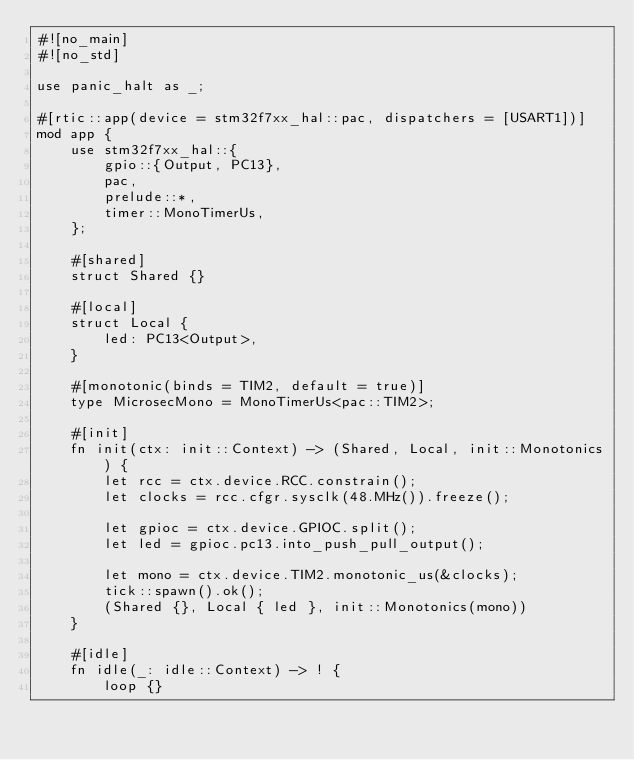Convert code to text. <code><loc_0><loc_0><loc_500><loc_500><_Rust_>#![no_main]
#![no_std]

use panic_halt as _;

#[rtic::app(device = stm32f7xx_hal::pac, dispatchers = [USART1])]
mod app {
    use stm32f7xx_hal::{
        gpio::{Output, PC13},
        pac,
        prelude::*,
        timer::MonoTimerUs,
    };

    #[shared]
    struct Shared {}

    #[local]
    struct Local {
        led: PC13<Output>,
    }

    #[monotonic(binds = TIM2, default = true)]
    type MicrosecMono = MonoTimerUs<pac::TIM2>;

    #[init]
    fn init(ctx: init::Context) -> (Shared, Local, init::Monotonics) {
        let rcc = ctx.device.RCC.constrain();
        let clocks = rcc.cfgr.sysclk(48.MHz()).freeze();

        let gpioc = ctx.device.GPIOC.split();
        let led = gpioc.pc13.into_push_pull_output();

        let mono = ctx.device.TIM2.monotonic_us(&clocks);
        tick::spawn().ok();
        (Shared {}, Local { led }, init::Monotonics(mono))
    }

    #[idle]
    fn idle(_: idle::Context) -> ! {
        loop {}</code> 